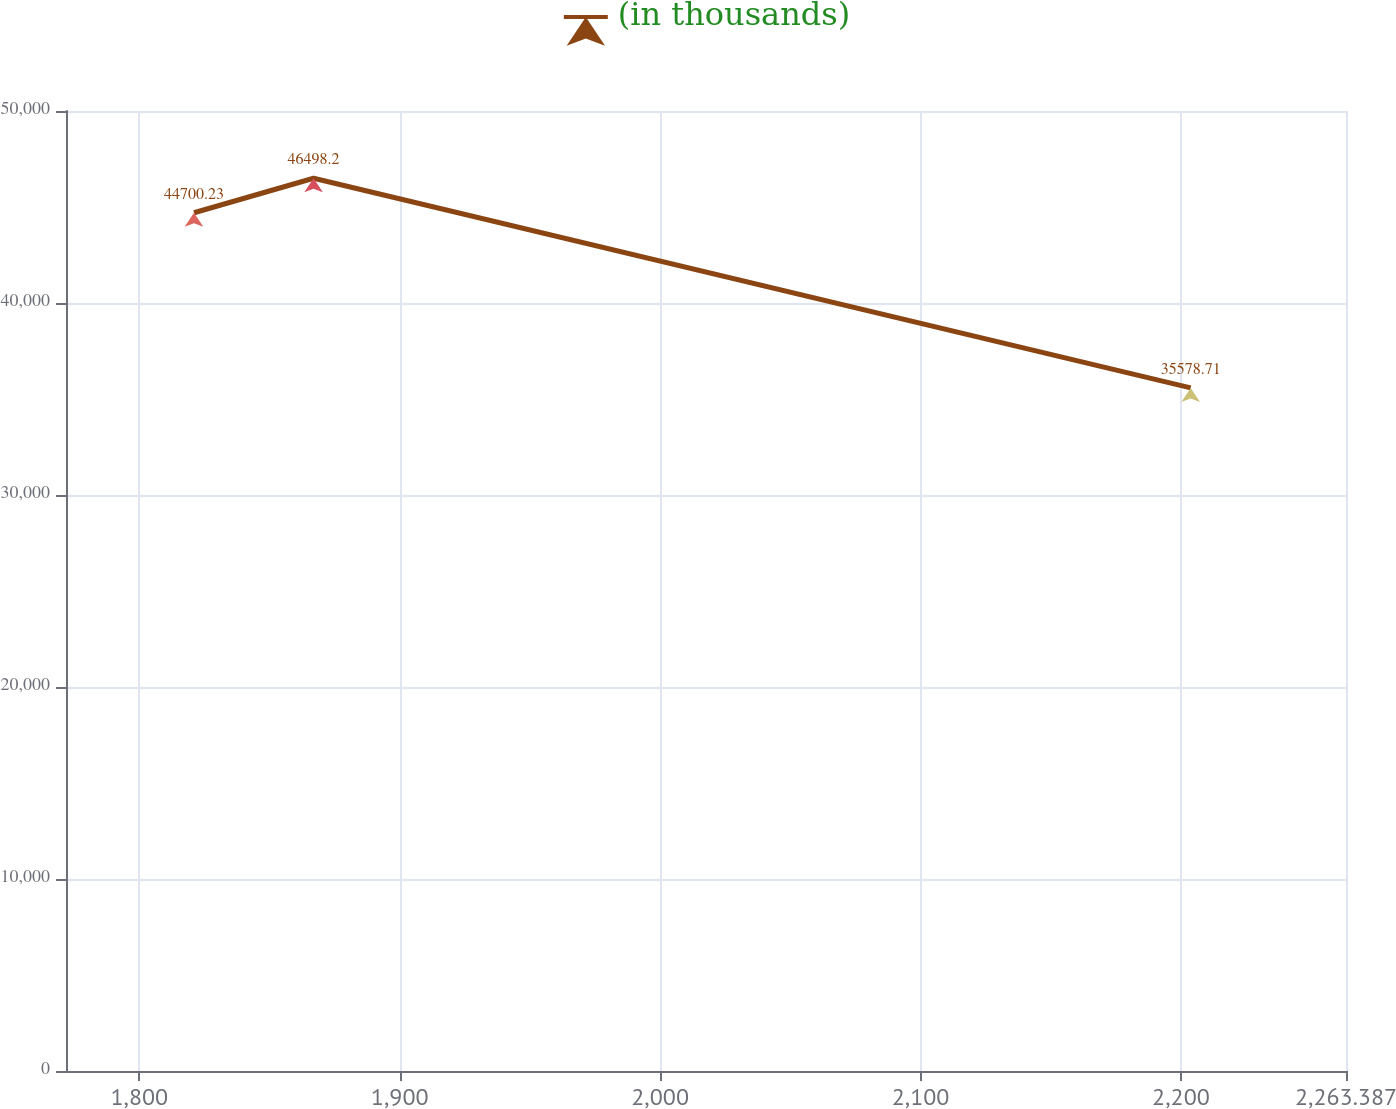Convert chart. <chart><loc_0><loc_0><loc_500><loc_500><line_chart><ecel><fcel>(in thousands)<nl><fcel>1821.01<fcel>44700.2<nl><fcel>1866.93<fcel>46498.2<nl><fcel>2203.75<fcel>35578.7<nl><fcel>2266.62<fcel>32267.8<nl><fcel>2312.54<fcel>28238.3<nl></chart> 